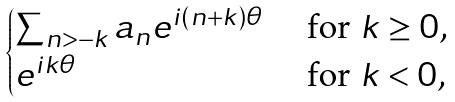<formula> <loc_0><loc_0><loc_500><loc_500>\begin{cases} \sum _ { n > - k } a _ { n } e ^ { i ( n + k ) \theta } & \text { for $k\geq 0$,} \\ e ^ { i k \theta } & \text { for $k < 0$,} \end{cases}</formula> 